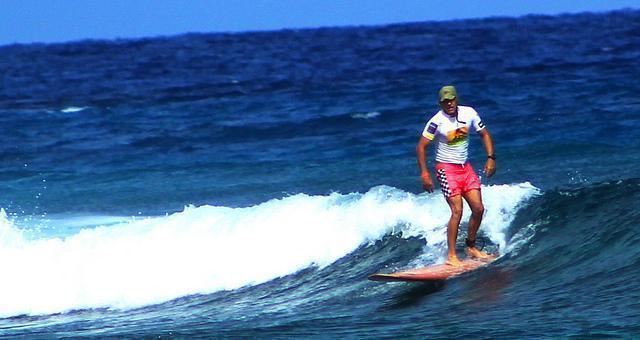What might he have applied before going out there?
Answer the question by selecting the correct answer among the 4 following choices and explain your choice with a short sentence. The answer should be formatted with the following format: `Answer: choice
Rationale: rationale.`
Options: Hairspray, lipstick, sunscreen, foundation. Answer: sunscreen.
Rationale: The man is under the sun so perhaps needed something to protect his skin. 